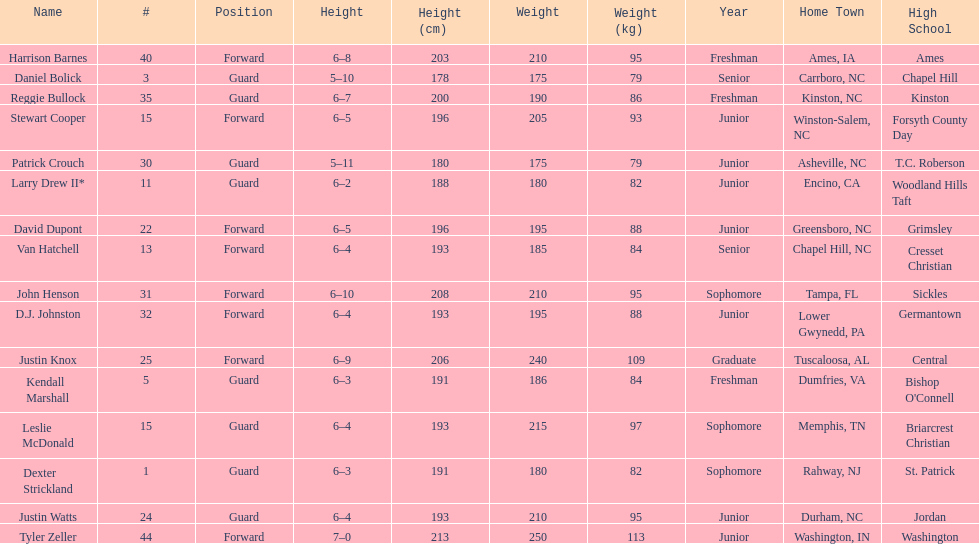Names of players who were exactly 6 feet, 4 inches tall, but did not weight over 200 pounds Van Hatchell, D.J. Johnston. 